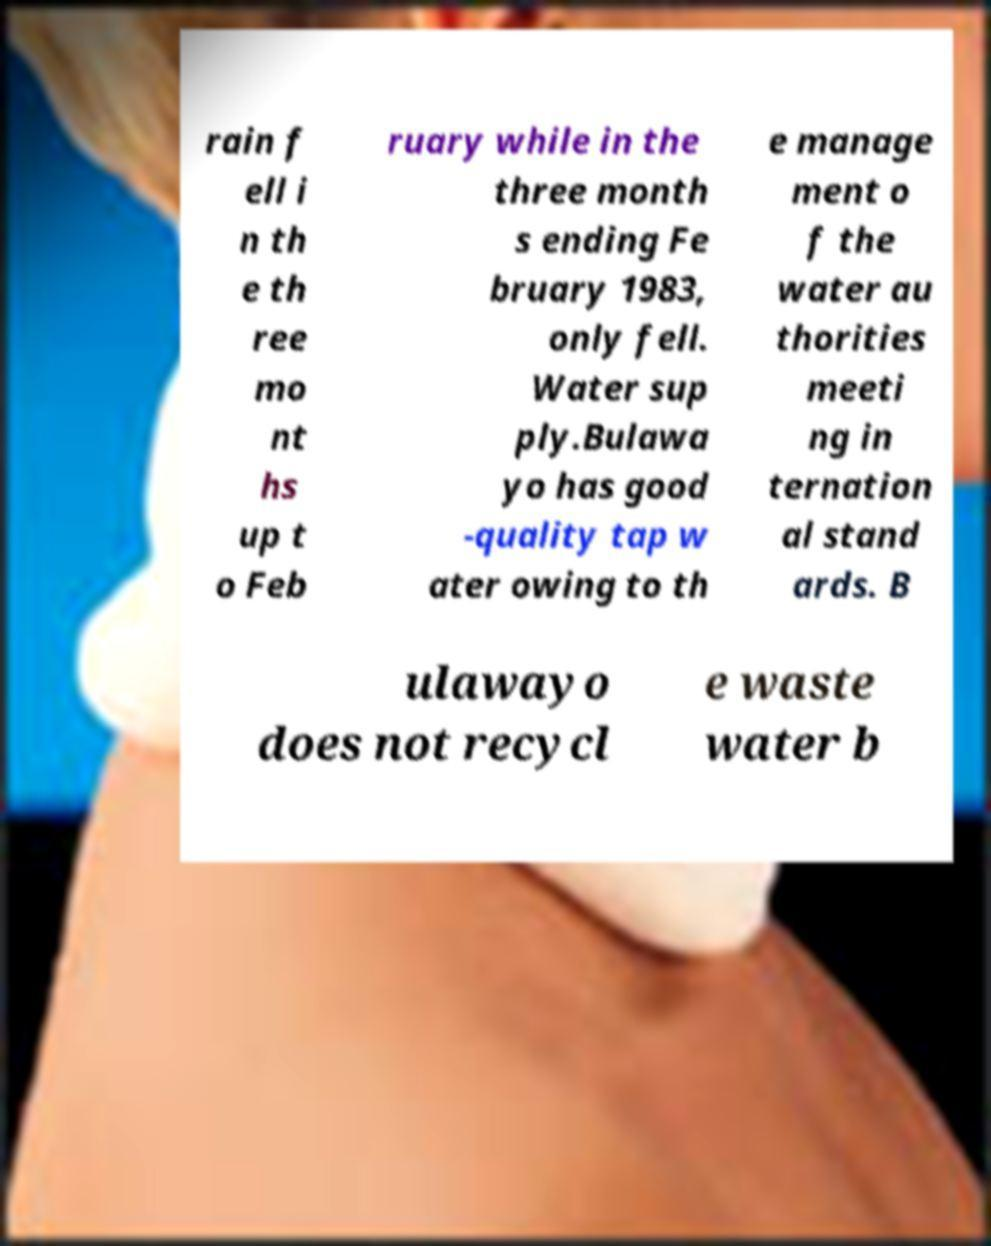Could you assist in decoding the text presented in this image and type it out clearly? rain f ell i n th e th ree mo nt hs up t o Feb ruary while in the three month s ending Fe bruary 1983, only fell. Water sup ply.Bulawa yo has good -quality tap w ater owing to th e manage ment o f the water au thorities meeti ng in ternation al stand ards. B ulawayo does not recycl e waste water b 